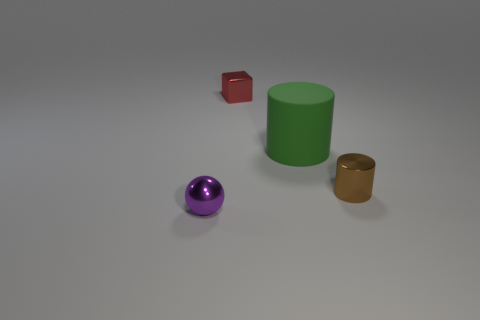Does the small brown thing have the same material as the cylinder behind the tiny metal cylinder?
Make the answer very short. No. What is the color of the large matte cylinder?
Ensure brevity in your answer.  Green. There is a metallic thing that is on the left side of the small shiny thing that is behind the brown shiny cylinder; what number of purple spheres are to the right of it?
Give a very brief answer. 0. Are there any green cylinders left of the big green cylinder?
Your answer should be very brief. No. What number of tiny blue cubes have the same material as the purple thing?
Keep it short and to the point. 0. What number of objects are either tiny cyan rubber things or small brown shiny objects?
Your answer should be compact. 1. Is there a large cylinder?
Give a very brief answer. Yes. The big object that is right of the shiny thing behind the metal object to the right of the small red metallic object is made of what material?
Offer a very short reply. Rubber. Is the number of tiny objects in front of the small ball less than the number of big cylinders?
Your response must be concise. Yes. There is a purple thing that is the same size as the red shiny object; what is its material?
Make the answer very short. Metal. 